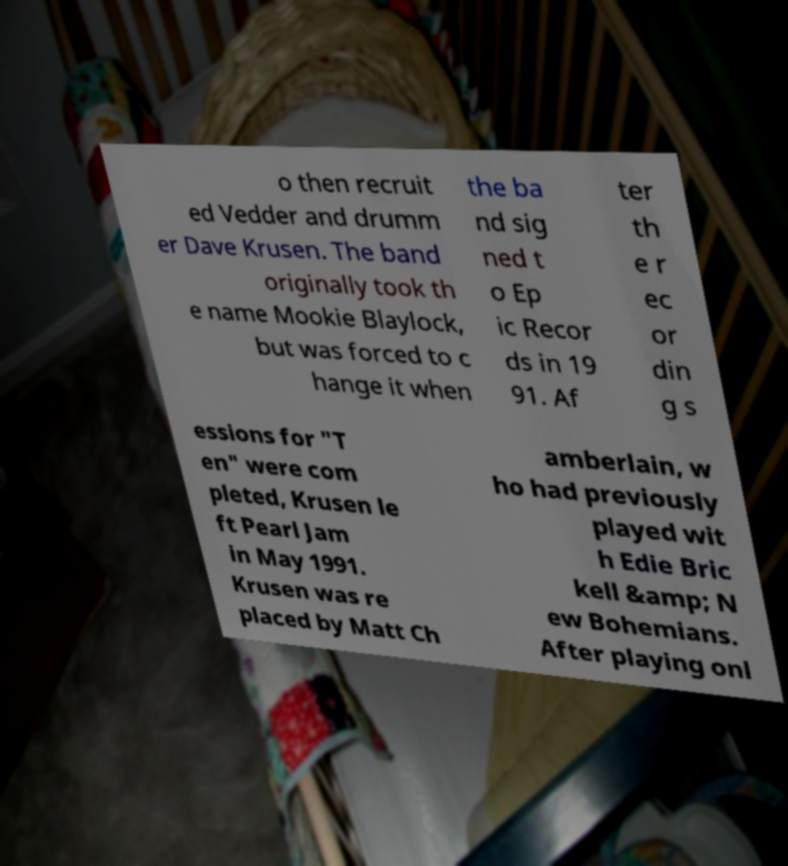Can you accurately transcribe the text from the provided image for me? o then recruit ed Vedder and drumm er Dave Krusen. The band originally took th e name Mookie Blaylock, but was forced to c hange it when the ba nd sig ned t o Ep ic Recor ds in 19 91. Af ter th e r ec or din g s essions for "T en" were com pleted, Krusen le ft Pearl Jam in May 1991. Krusen was re placed by Matt Ch amberlain, w ho had previously played wit h Edie Bric kell &amp; N ew Bohemians. After playing onl 